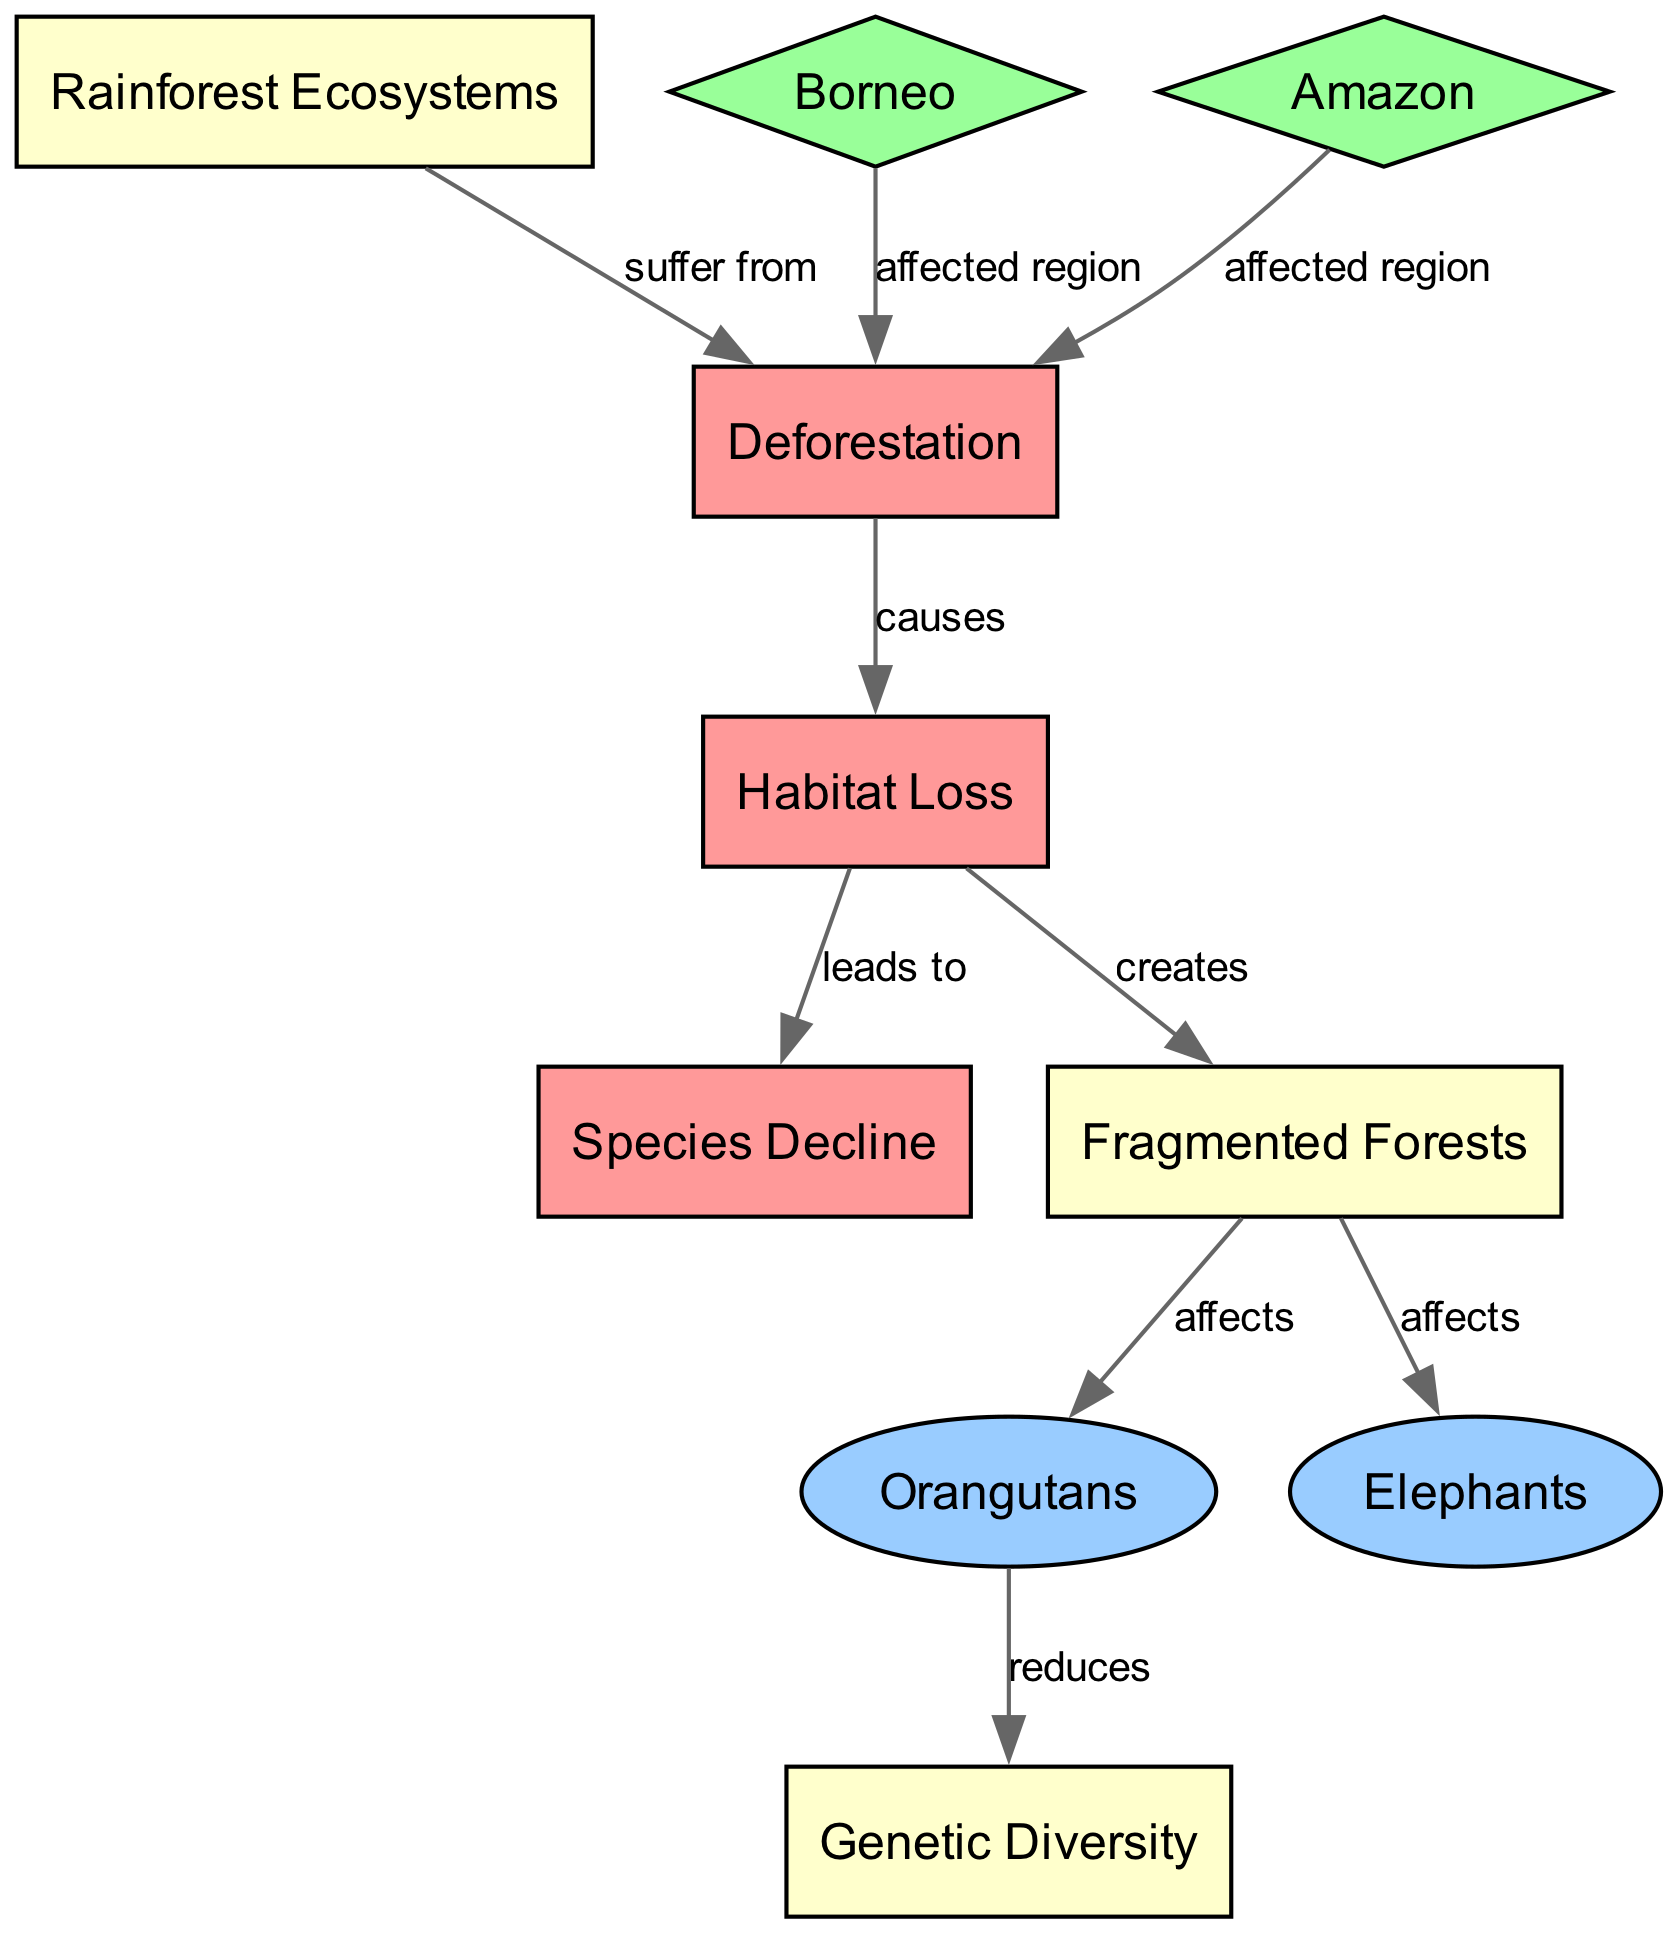What is the main cause of habitat loss? The diagram indicates that deforestation is the root cause that leads to habitat loss. The directed edge labeled "causes" connects the "Deforestation" node to the "Habitat Loss" node.
Answer: Deforestation How many species are mentioned in the diagram? The diagram highlights two specific species, "Orangutans" and "Elephants," connected to the "Fragmented Forests" node. There are no other species listed, making the total two.
Answer: 2 What type of ecosystem suffers from deforestation? The diagram clearly states that rainforest ecosystems suffer from deforestation as shown by the edge labeled "suffer from" connecting the "Rainforest Ecosystems" node to the "Deforestation" node.
Answer: Rainforest Ecosystems Which region is affected by deforestation as indicated in the diagram? The diagram lists two regions specifically affected by deforestation: "Borneo" and "Amazon." Each of these regions is linked to the "Deforestation" node by directed edges labeled "affected region."
Answer: Borneo and Amazon What is the impact of fragmented forests on orangutans? According to the diagram, fragmented forests "affect" the population of orangutans, as indicated by the directed edge connecting "Fragmented Forests" to "Orangutans" labeled "affects."
Answer: Affects How does habitat loss influence species decline? The diagram shows a direct connection where habitat loss leads to a decline in species, as described by the directed edge labeled "leads to" from "Habitat Loss" to "Species Decline." This indicates that the loss of habitat directly results in fewer species.
Answer: Leads to What aspect of biodiversity is reduced due to deforestation? The diagram illustrates that deforestation reduces genetic diversity, which is connected to the "Orangutans" node through a directed edge labeled "reduces." This highlights the loss of genetic variations essential for species' survival.
Answer: Genetic Diversity What creates fragmented forests? The diagram indicates that habitat loss creates fragmented forests, as shown by the directed edge labeled "creates," connecting "Habitat Loss" to "Fragmented Forests."
Answer: Creates How does habitat loss relate to elephants? The diagram specifies that fragmented forests affect elephants, indicated by the directed edge that connects "Fragmented Forests" to "Elephants" labeled "affects." This connection shows the impact of habitat fragmentation on this species.
Answer: Affects 